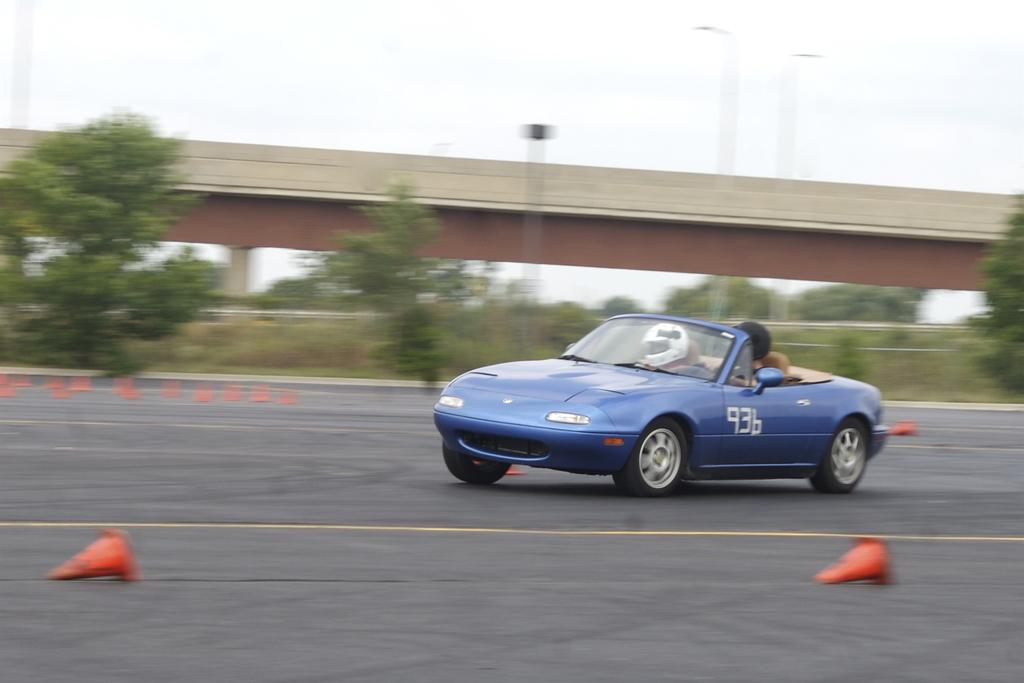What is the main subject of the image? There is a vehicle in the image. Are there any passengers in the vehicle? Yes, there are people in the vehicle. What is the vehicle doing in the image? The vehicle is moving on the road. What type of natural environment can be seen in the image? There are trees and grass in the image. What type of man-made structure is present in the image? There is a bridge in the image. What type of canvas is visible in the image? There is no canvas present in the image. How deep is the hole in the image? There is no hole present in the image. 